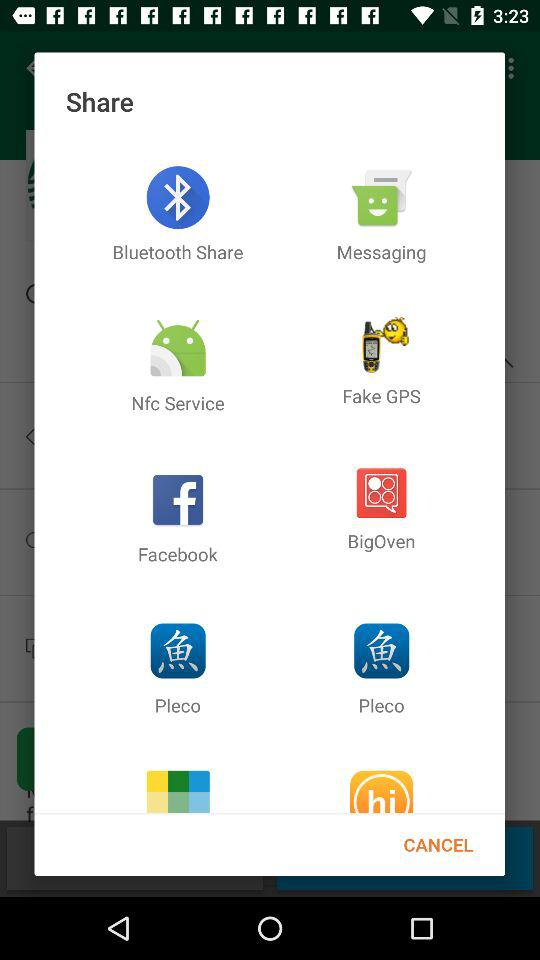Through which application can we share? You can share through "Bluetooth Share", "Messaging", "Nfc Service", "Fake GPS", "Facebook", "BigOven" and "Pleco". 